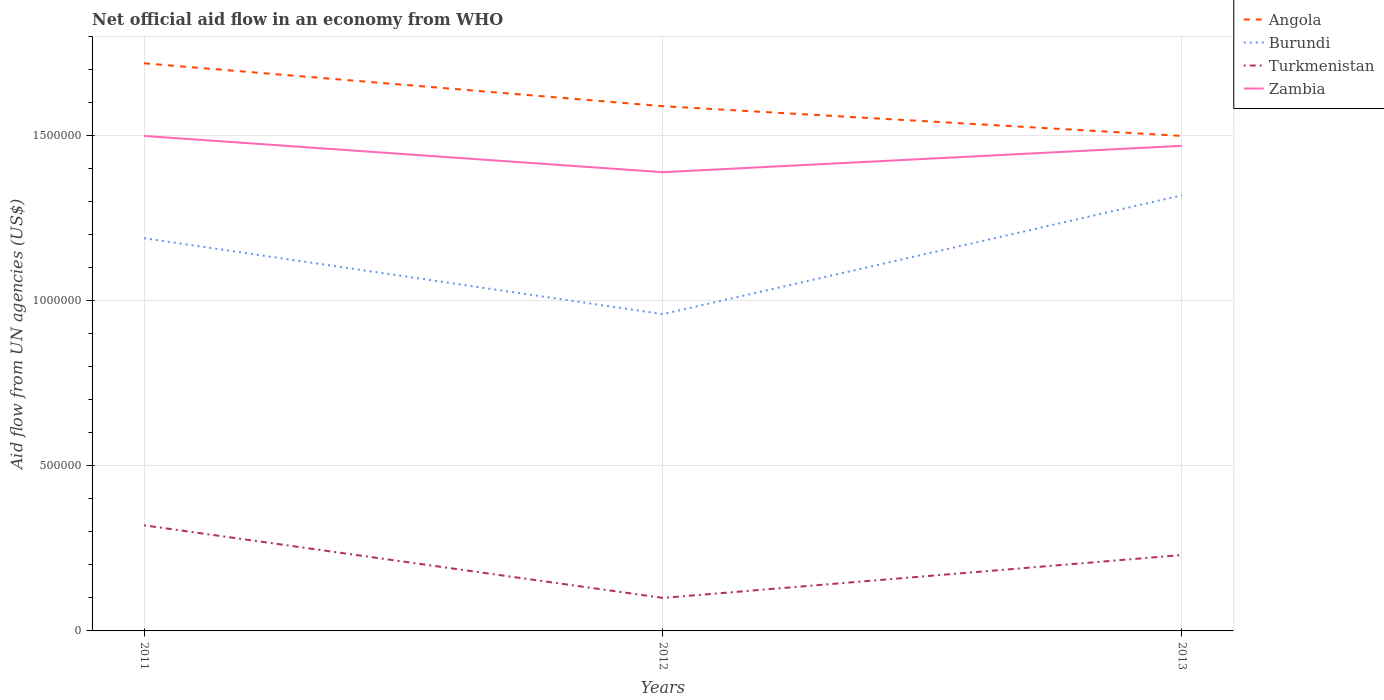How many different coloured lines are there?
Offer a terse response. 4. Across all years, what is the maximum net official aid flow in Burundi?
Your response must be concise. 9.60e+05. In which year was the net official aid flow in Turkmenistan maximum?
Provide a short and direct response. 2012. Is the net official aid flow in Zambia strictly greater than the net official aid flow in Angola over the years?
Offer a very short reply. Yes. How many lines are there?
Make the answer very short. 4. How many years are there in the graph?
Provide a short and direct response. 3. Where does the legend appear in the graph?
Your answer should be compact. Top right. How many legend labels are there?
Keep it short and to the point. 4. What is the title of the graph?
Make the answer very short. Net official aid flow in an economy from WHO. What is the label or title of the X-axis?
Your response must be concise. Years. What is the label or title of the Y-axis?
Offer a very short reply. Aid flow from UN agencies (US$). What is the Aid flow from UN agencies (US$) in Angola in 2011?
Your response must be concise. 1.72e+06. What is the Aid flow from UN agencies (US$) of Burundi in 2011?
Provide a succinct answer. 1.19e+06. What is the Aid flow from UN agencies (US$) of Zambia in 2011?
Ensure brevity in your answer.  1.50e+06. What is the Aid flow from UN agencies (US$) in Angola in 2012?
Your response must be concise. 1.59e+06. What is the Aid flow from UN agencies (US$) in Burundi in 2012?
Your answer should be compact. 9.60e+05. What is the Aid flow from UN agencies (US$) in Turkmenistan in 2012?
Give a very brief answer. 1.00e+05. What is the Aid flow from UN agencies (US$) of Zambia in 2012?
Provide a short and direct response. 1.39e+06. What is the Aid flow from UN agencies (US$) in Angola in 2013?
Your response must be concise. 1.50e+06. What is the Aid flow from UN agencies (US$) of Burundi in 2013?
Provide a succinct answer. 1.32e+06. What is the Aid flow from UN agencies (US$) in Zambia in 2013?
Offer a terse response. 1.47e+06. Across all years, what is the maximum Aid flow from UN agencies (US$) of Angola?
Your answer should be compact. 1.72e+06. Across all years, what is the maximum Aid flow from UN agencies (US$) in Burundi?
Give a very brief answer. 1.32e+06. Across all years, what is the maximum Aid flow from UN agencies (US$) in Turkmenistan?
Give a very brief answer. 3.20e+05. Across all years, what is the maximum Aid flow from UN agencies (US$) of Zambia?
Ensure brevity in your answer.  1.50e+06. Across all years, what is the minimum Aid flow from UN agencies (US$) in Angola?
Keep it short and to the point. 1.50e+06. Across all years, what is the minimum Aid flow from UN agencies (US$) in Burundi?
Provide a short and direct response. 9.60e+05. Across all years, what is the minimum Aid flow from UN agencies (US$) of Zambia?
Your answer should be compact. 1.39e+06. What is the total Aid flow from UN agencies (US$) of Angola in the graph?
Your response must be concise. 4.81e+06. What is the total Aid flow from UN agencies (US$) of Burundi in the graph?
Offer a terse response. 3.47e+06. What is the total Aid flow from UN agencies (US$) in Turkmenistan in the graph?
Keep it short and to the point. 6.50e+05. What is the total Aid flow from UN agencies (US$) of Zambia in the graph?
Provide a succinct answer. 4.36e+06. What is the difference between the Aid flow from UN agencies (US$) of Angola in 2011 and that in 2012?
Provide a short and direct response. 1.30e+05. What is the difference between the Aid flow from UN agencies (US$) in Angola in 2011 and that in 2013?
Provide a short and direct response. 2.20e+05. What is the difference between the Aid flow from UN agencies (US$) in Burundi in 2011 and that in 2013?
Give a very brief answer. -1.30e+05. What is the difference between the Aid flow from UN agencies (US$) of Zambia in 2011 and that in 2013?
Ensure brevity in your answer.  3.00e+04. What is the difference between the Aid flow from UN agencies (US$) in Burundi in 2012 and that in 2013?
Provide a short and direct response. -3.60e+05. What is the difference between the Aid flow from UN agencies (US$) in Turkmenistan in 2012 and that in 2013?
Your answer should be very brief. -1.30e+05. What is the difference between the Aid flow from UN agencies (US$) in Angola in 2011 and the Aid flow from UN agencies (US$) in Burundi in 2012?
Your answer should be compact. 7.60e+05. What is the difference between the Aid flow from UN agencies (US$) of Angola in 2011 and the Aid flow from UN agencies (US$) of Turkmenistan in 2012?
Ensure brevity in your answer.  1.62e+06. What is the difference between the Aid flow from UN agencies (US$) of Burundi in 2011 and the Aid flow from UN agencies (US$) of Turkmenistan in 2012?
Offer a terse response. 1.09e+06. What is the difference between the Aid flow from UN agencies (US$) in Turkmenistan in 2011 and the Aid flow from UN agencies (US$) in Zambia in 2012?
Your answer should be compact. -1.07e+06. What is the difference between the Aid flow from UN agencies (US$) in Angola in 2011 and the Aid flow from UN agencies (US$) in Turkmenistan in 2013?
Offer a terse response. 1.49e+06. What is the difference between the Aid flow from UN agencies (US$) in Burundi in 2011 and the Aid flow from UN agencies (US$) in Turkmenistan in 2013?
Offer a terse response. 9.60e+05. What is the difference between the Aid flow from UN agencies (US$) in Burundi in 2011 and the Aid flow from UN agencies (US$) in Zambia in 2013?
Provide a short and direct response. -2.80e+05. What is the difference between the Aid flow from UN agencies (US$) of Turkmenistan in 2011 and the Aid flow from UN agencies (US$) of Zambia in 2013?
Offer a terse response. -1.15e+06. What is the difference between the Aid flow from UN agencies (US$) in Angola in 2012 and the Aid flow from UN agencies (US$) in Turkmenistan in 2013?
Give a very brief answer. 1.36e+06. What is the difference between the Aid flow from UN agencies (US$) of Burundi in 2012 and the Aid flow from UN agencies (US$) of Turkmenistan in 2013?
Your answer should be very brief. 7.30e+05. What is the difference between the Aid flow from UN agencies (US$) of Burundi in 2012 and the Aid flow from UN agencies (US$) of Zambia in 2013?
Your answer should be compact. -5.10e+05. What is the difference between the Aid flow from UN agencies (US$) of Turkmenistan in 2012 and the Aid flow from UN agencies (US$) of Zambia in 2013?
Offer a very short reply. -1.37e+06. What is the average Aid flow from UN agencies (US$) of Angola per year?
Ensure brevity in your answer.  1.60e+06. What is the average Aid flow from UN agencies (US$) of Burundi per year?
Provide a short and direct response. 1.16e+06. What is the average Aid flow from UN agencies (US$) in Turkmenistan per year?
Provide a succinct answer. 2.17e+05. What is the average Aid flow from UN agencies (US$) in Zambia per year?
Make the answer very short. 1.45e+06. In the year 2011, what is the difference between the Aid flow from UN agencies (US$) of Angola and Aid flow from UN agencies (US$) of Burundi?
Keep it short and to the point. 5.30e+05. In the year 2011, what is the difference between the Aid flow from UN agencies (US$) in Angola and Aid flow from UN agencies (US$) in Turkmenistan?
Your answer should be very brief. 1.40e+06. In the year 2011, what is the difference between the Aid flow from UN agencies (US$) of Angola and Aid flow from UN agencies (US$) of Zambia?
Ensure brevity in your answer.  2.20e+05. In the year 2011, what is the difference between the Aid flow from UN agencies (US$) in Burundi and Aid flow from UN agencies (US$) in Turkmenistan?
Provide a short and direct response. 8.70e+05. In the year 2011, what is the difference between the Aid flow from UN agencies (US$) of Burundi and Aid flow from UN agencies (US$) of Zambia?
Your answer should be very brief. -3.10e+05. In the year 2011, what is the difference between the Aid flow from UN agencies (US$) of Turkmenistan and Aid flow from UN agencies (US$) of Zambia?
Ensure brevity in your answer.  -1.18e+06. In the year 2012, what is the difference between the Aid flow from UN agencies (US$) in Angola and Aid flow from UN agencies (US$) in Burundi?
Your answer should be compact. 6.30e+05. In the year 2012, what is the difference between the Aid flow from UN agencies (US$) in Angola and Aid flow from UN agencies (US$) in Turkmenistan?
Make the answer very short. 1.49e+06. In the year 2012, what is the difference between the Aid flow from UN agencies (US$) of Angola and Aid flow from UN agencies (US$) of Zambia?
Ensure brevity in your answer.  2.00e+05. In the year 2012, what is the difference between the Aid flow from UN agencies (US$) in Burundi and Aid flow from UN agencies (US$) in Turkmenistan?
Your answer should be compact. 8.60e+05. In the year 2012, what is the difference between the Aid flow from UN agencies (US$) in Burundi and Aid flow from UN agencies (US$) in Zambia?
Your answer should be very brief. -4.30e+05. In the year 2012, what is the difference between the Aid flow from UN agencies (US$) of Turkmenistan and Aid flow from UN agencies (US$) of Zambia?
Offer a very short reply. -1.29e+06. In the year 2013, what is the difference between the Aid flow from UN agencies (US$) of Angola and Aid flow from UN agencies (US$) of Burundi?
Your answer should be very brief. 1.80e+05. In the year 2013, what is the difference between the Aid flow from UN agencies (US$) of Angola and Aid flow from UN agencies (US$) of Turkmenistan?
Offer a very short reply. 1.27e+06. In the year 2013, what is the difference between the Aid flow from UN agencies (US$) in Angola and Aid flow from UN agencies (US$) in Zambia?
Provide a short and direct response. 3.00e+04. In the year 2013, what is the difference between the Aid flow from UN agencies (US$) in Burundi and Aid flow from UN agencies (US$) in Turkmenistan?
Give a very brief answer. 1.09e+06. In the year 2013, what is the difference between the Aid flow from UN agencies (US$) of Burundi and Aid flow from UN agencies (US$) of Zambia?
Keep it short and to the point. -1.50e+05. In the year 2013, what is the difference between the Aid flow from UN agencies (US$) of Turkmenistan and Aid flow from UN agencies (US$) of Zambia?
Your answer should be compact. -1.24e+06. What is the ratio of the Aid flow from UN agencies (US$) of Angola in 2011 to that in 2012?
Keep it short and to the point. 1.08. What is the ratio of the Aid flow from UN agencies (US$) in Burundi in 2011 to that in 2012?
Ensure brevity in your answer.  1.24. What is the ratio of the Aid flow from UN agencies (US$) in Zambia in 2011 to that in 2012?
Offer a very short reply. 1.08. What is the ratio of the Aid flow from UN agencies (US$) in Angola in 2011 to that in 2013?
Your response must be concise. 1.15. What is the ratio of the Aid flow from UN agencies (US$) in Burundi in 2011 to that in 2013?
Ensure brevity in your answer.  0.9. What is the ratio of the Aid flow from UN agencies (US$) in Turkmenistan in 2011 to that in 2013?
Provide a succinct answer. 1.39. What is the ratio of the Aid flow from UN agencies (US$) of Zambia in 2011 to that in 2013?
Offer a terse response. 1.02. What is the ratio of the Aid flow from UN agencies (US$) of Angola in 2012 to that in 2013?
Your answer should be very brief. 1.06. What is the ratio of the Aid flow from UN agencies (US$) of Burundi in 2012 to that in 2013?
Your response must be concise. 0.73. What is the ratio of the Aid flow from UN agencies (US$) in Turkmenistan in 2012 to that in 2013?
Give a very brief answer. 0.43. What is the ratio of the Aid flow from UN agencies (US$) of Zambia in 2012 to that in 2013?
Your answer should be very brief. 0.95. What is the difference between the highest and the second highest Aid flow from UN agencies (US$) of Angola?
Your answer should be very brief. 1.30e+05. What is the difference between the highest and the second highest Aid flow from UN agencies (US$) of Zambia?
Offer a very short reply. 3.00e+04. What is the difference between the highest and the lowest Aid flow from UN agencies (US$) of Angola?
Give a very brief answer. 2.20e+05. What is the difference between the highest and the lowest Aid flow from UN agencies (US$) of Burundi?
Offer a very short reply. 3.60e+05. What is the difference between the highest and the lowest Aid flow from UN agencies (US$) of Zambia?
Offer a very short reply. 1.10e+05. 